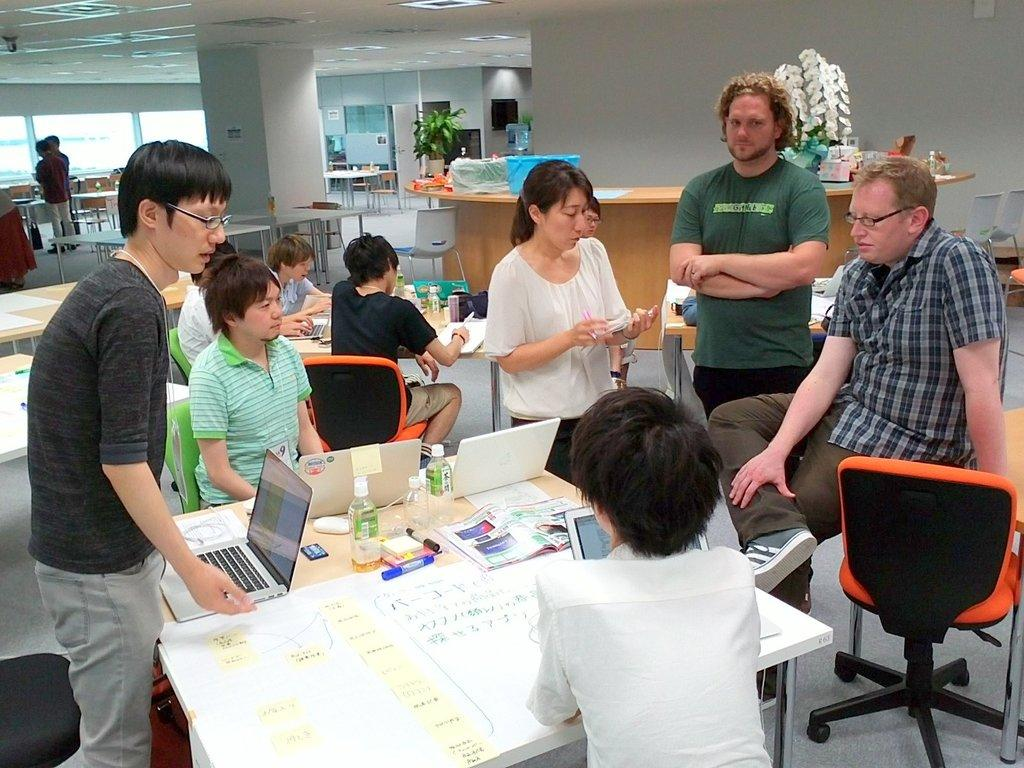What are the people in the image doing? The people in the image are sitting on chairs. How are the chairs arranged in the image? The chairs are arranged around a table. What can be found on the table in the image? There are things on the table. What is visible in the background of the image? There is a desk and other chairs and tables in the background of the image. What type of music is being played in the image? There is no indication of music being played in the image. What vegetables are present on the table in the image? There is no mention of vegetables in the image; the things on the table are not specified. 